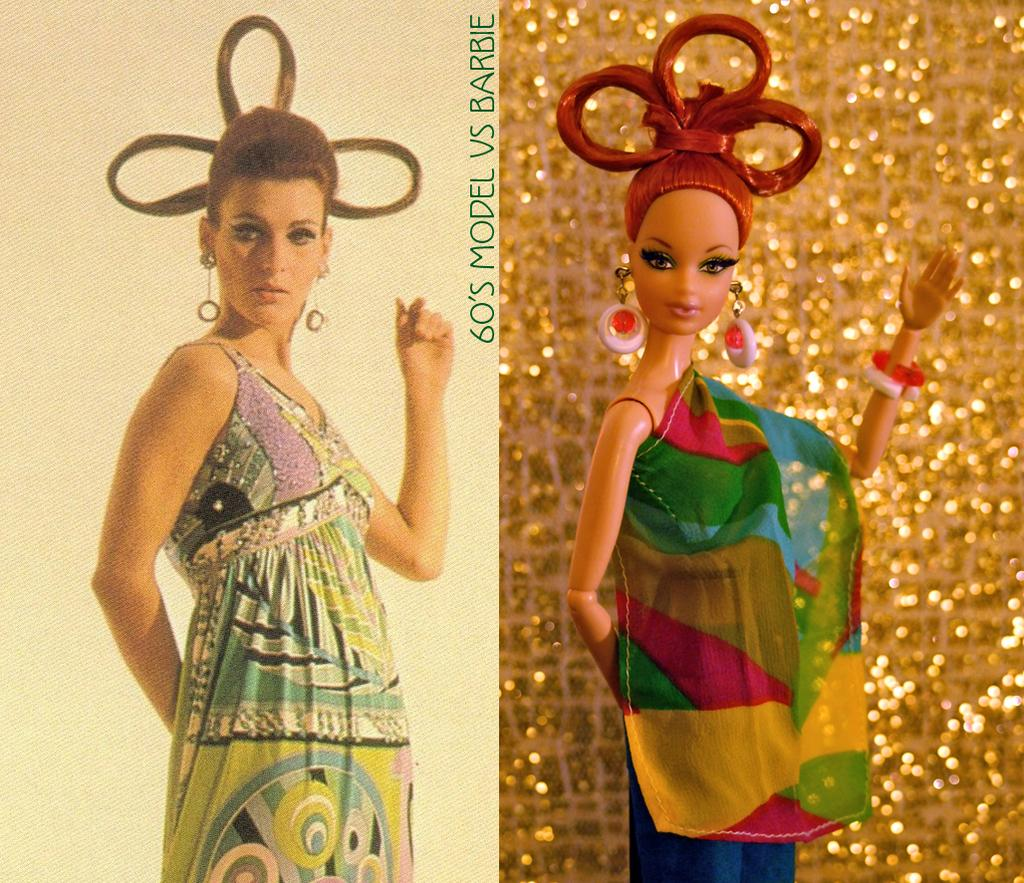What can be seen in the first part of the image? There is a poster in the first part of the image. What is featured in the second part of the image? There is a doll in the second part of the image. What riddle is the doll trying to solve in the image? There is no riddle present in the image, nor is the doll attempting to solve one. 